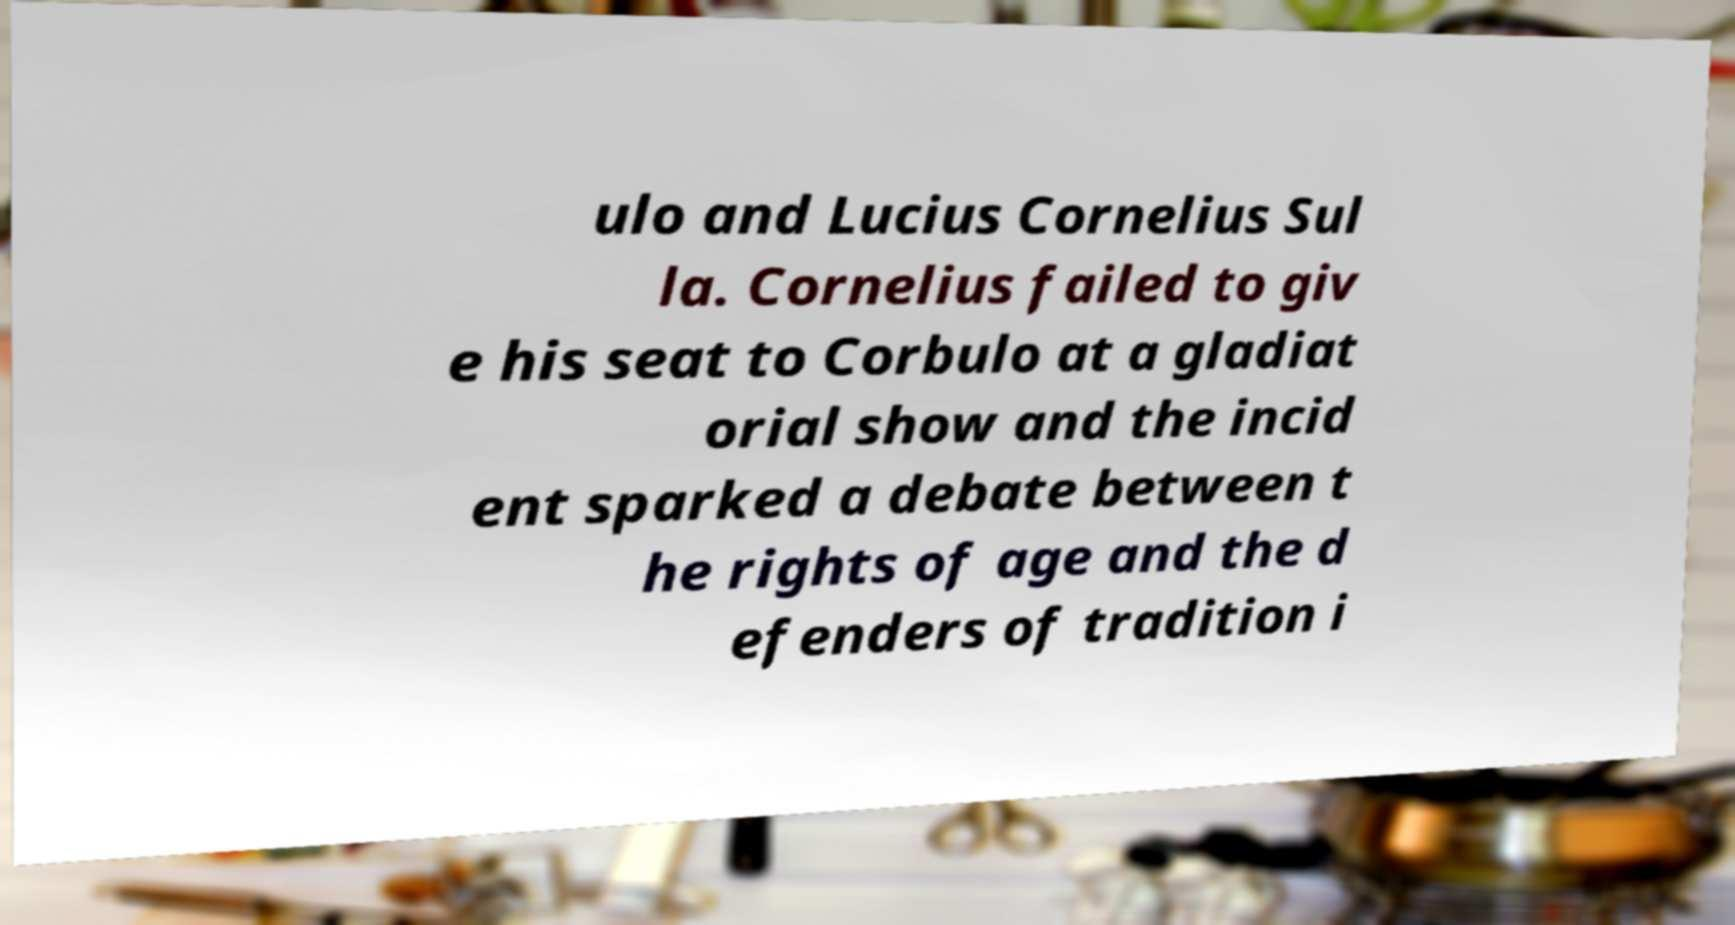Could you extract and type out the text from this image? ulo and Lucius Cornelius Sul la. Cornelius failed to giv e his seat to Corbulo at a gladiat orial show and the incid ent sparked a debate between t he rights of age and the d efenders of tradition i 